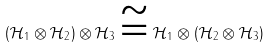<formula> <loc_0><loc_0><loc_500><loc_500>( \mathcal { H } _ { 1 } \otimes \mathcal { H } _ { 2 } ) \otimes \mathcal { H } _ { 3 } \cong \mathcal { H } _ { 1 } \otimes ( \mathcal { H } _ { 2 } \otimes \mathcal { H } _ { 3 } )</formula> 